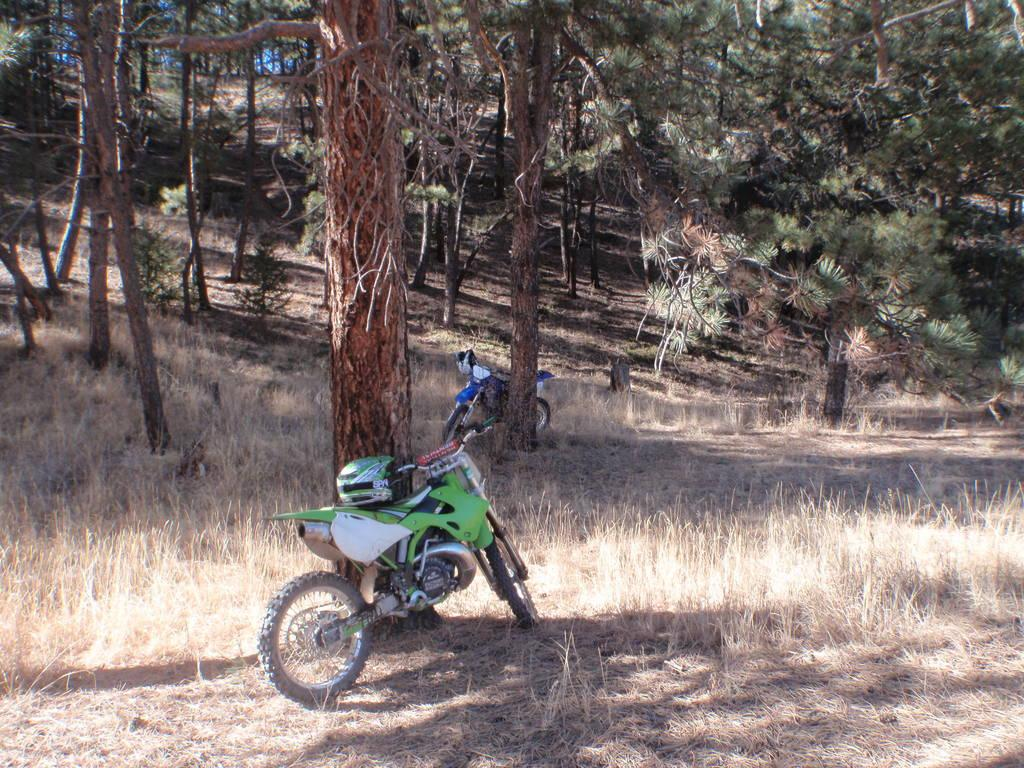What type of vehicles are in the image? There are two motorbikes in the image. What safety equipment is associated with the motorbikes? There are helmets in the image. What type of vegetation is visible behind the motorbikes? There is a group of trees visible behind the motorbikes. What type of ground surface is visible in the image? There is grass visible in the image. Where is the cemetery located in the image? There is no cemetery present in the image. What type of home can be seen in the background of the image? There is no home visible in the image; it features motorbikes, helmets, trees, and grass. 